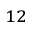<formula> <loc_0><loc_0><loc_500><loc_500>_ { 1 2 }</formula> 